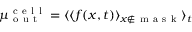Convert formula to latex. <formula><loc_0><loc_0><loc_500><loc_500>\mu _ { o u t } ^ { c e l l } = \langle \langle f ( x , t ) \rangle _ { x \notin m a s k } \rangle _ { t }</formula> 